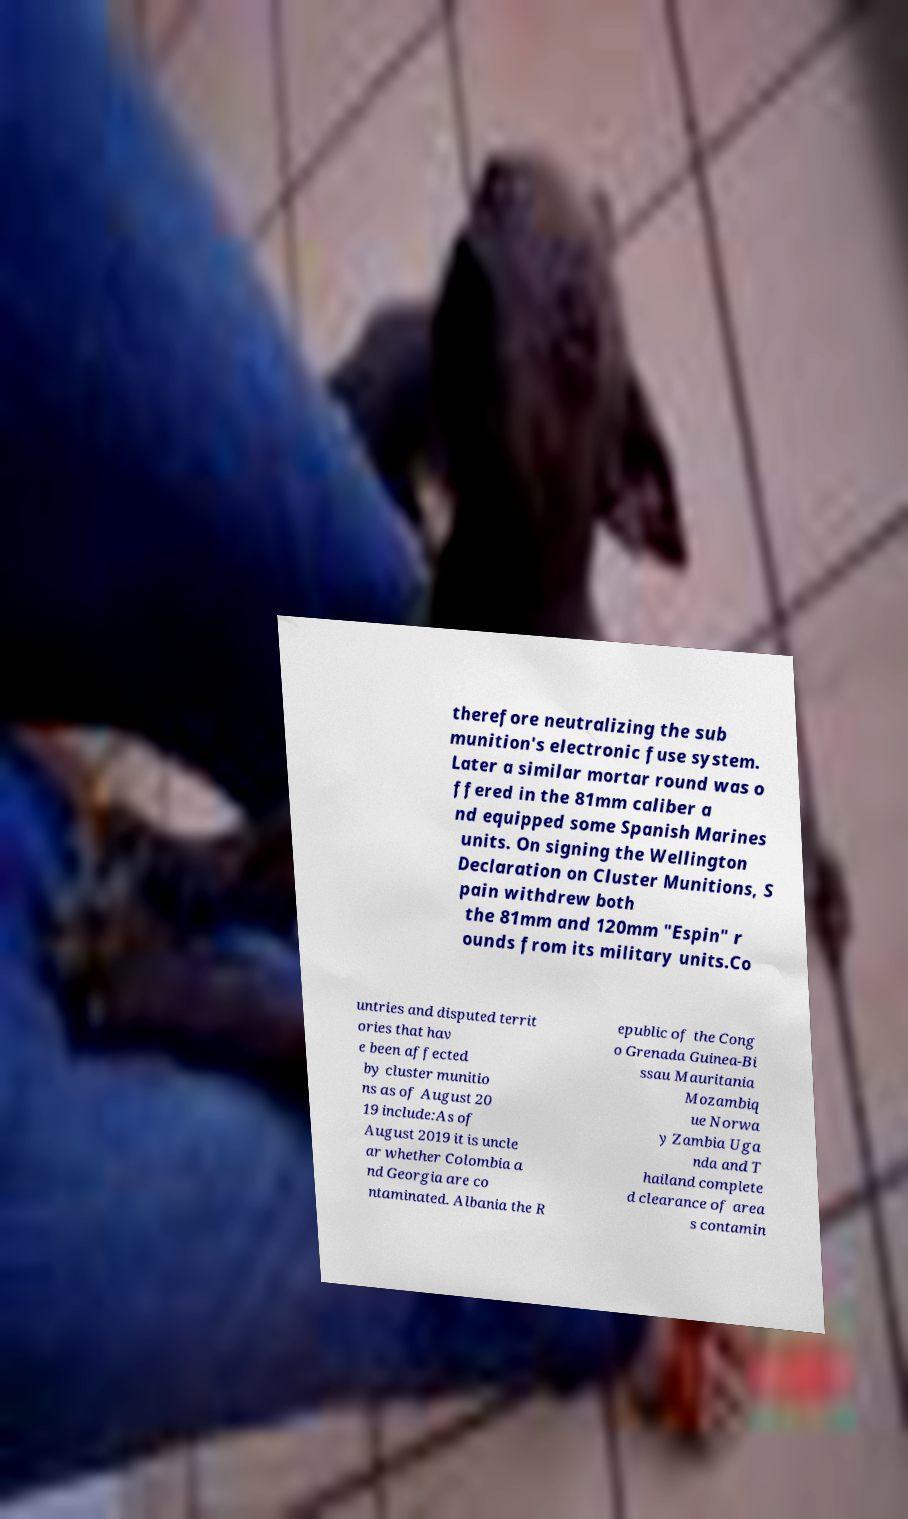For documentation purposes, I need the text within this image transcribed. Could you provide that? therefore neutralizing the sub munition's electronic fuse system. Later a similar mortar round was o ffered in the 81mm caliber a nd equipped some Spanish Marines units. On signing the Wellington Declaration on Cluster Munitions, S pain withdrew both the 81mm and 120mm "Espin" r ounds from its military units.Co untries and disputed territ ories that hav e been affected by cluster munitio ns as of August 20 19 include:As of August 2019 it is uncle ar whether Colombia a nd Georgia are co ntaminated. Albania the R epublic of the Cong o Grenada Guinea-Bi ssau Mauritania Mozambiq ue Norwa y Zambia Uga nda and T hailand complete d clearance of area s contamin 